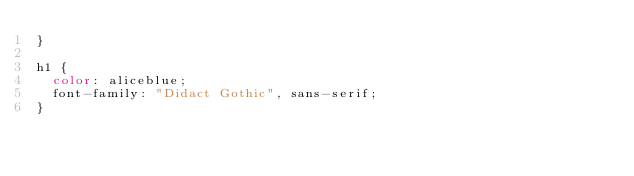<code> <loc_0><loc_0><loc_500><loc_500><_CSS_>}

h1 {
  color: aliceblue;
  font-family: "Didact Gothic", sans-serif;
}
</code> 